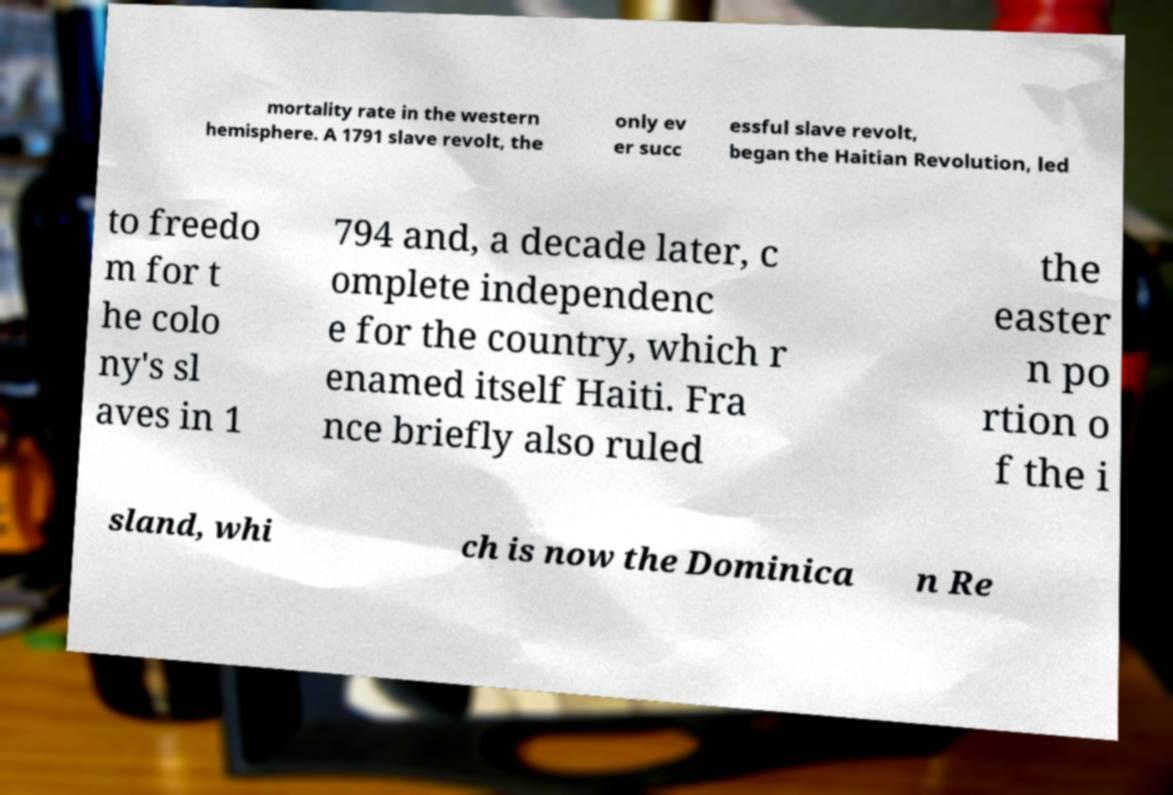Could you assist in decoding the text presented in this image and type it out clearly? mortality rate in the western hemisphere. A 1791 slave revolt, the only ev er succ essful slave revolt, began the Haitian Revolution, led to freedo m for t he colo ny's sl aves in 1 794 and, a decade later, c omplete independenc e for the country, which r enamed itself Haiti. Fra nce briefly also ruled the easter n po rtion o f the i sland, whi ch is now the Dominica n Re 